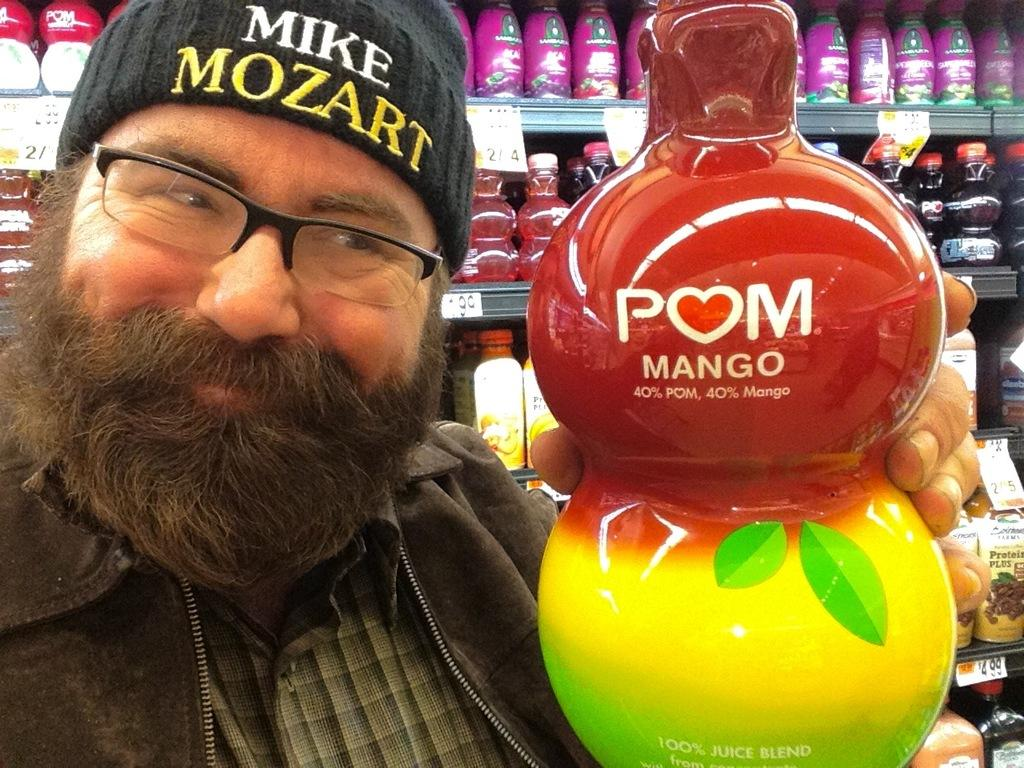What is the main subject of the image? There is a person standing in the middle of the image. What is the person holding in the image? The person is holding an object. What can be seen in the background of the image? There are bottles kept in racks in the background of the image. What type of flag is being compared to the object the person is holding in the image? There is no flag present in the image, and therefore no comparison can be made. 